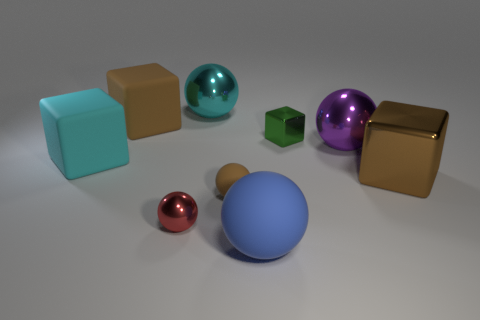What shape is the big brown thing on the left side of the small metallic object that is behind the large brown metallic thing?
Your answer should be very brief. Cube. Are there any cyan metallic spheres that have the same size as the blue ball?
Offer a terse response. Yes. How many other big matte things are the same shape as the red object?
Ensure brevity in your answer.  1. Are there an equal number of purple things left of the cyan rubber object and brown blocks left of the large brown matte cube?
Offer a terse response. Yes. Is there a large cyan rubber block?
Your response must be concise. Yes. There is a brown rubber object that is left of the large metallic ball that is left of the big ball that is in front of the brown metallic thing; what is its size?
Provide a succinct answer. Large. There is a matte thing that is the same size as the red sphere; what shape is it?
Your answer should be compact. Sphere. Is there anything else that has the same material as the green block?
Offer a terse response. Yes. What number of objects are either big things on the right side of the purple shiny thing or small cyan rubber blocks?
Keep it short and to the point. 1. There is a brown cube that is to the right of the tiny object that is behind the brown metal thing; is there a red object to the right of it?
Your answer should be very brief. No. 